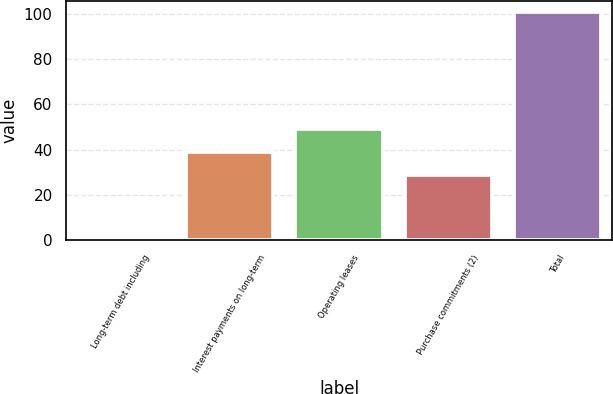Convert chart. <chart><loc_0><loc_0><loc_500><loc_500><bar_chart><fcel>Long-term debt including<fcel>Interest payments on long-term<fcel>Operating leases<fcel>Purchase commitments (2)<fcel>Total<nl><fcel>1<fcel>39.07<fcel>49.04<fcel>29.1<fcel>100.7<nl></chart> 